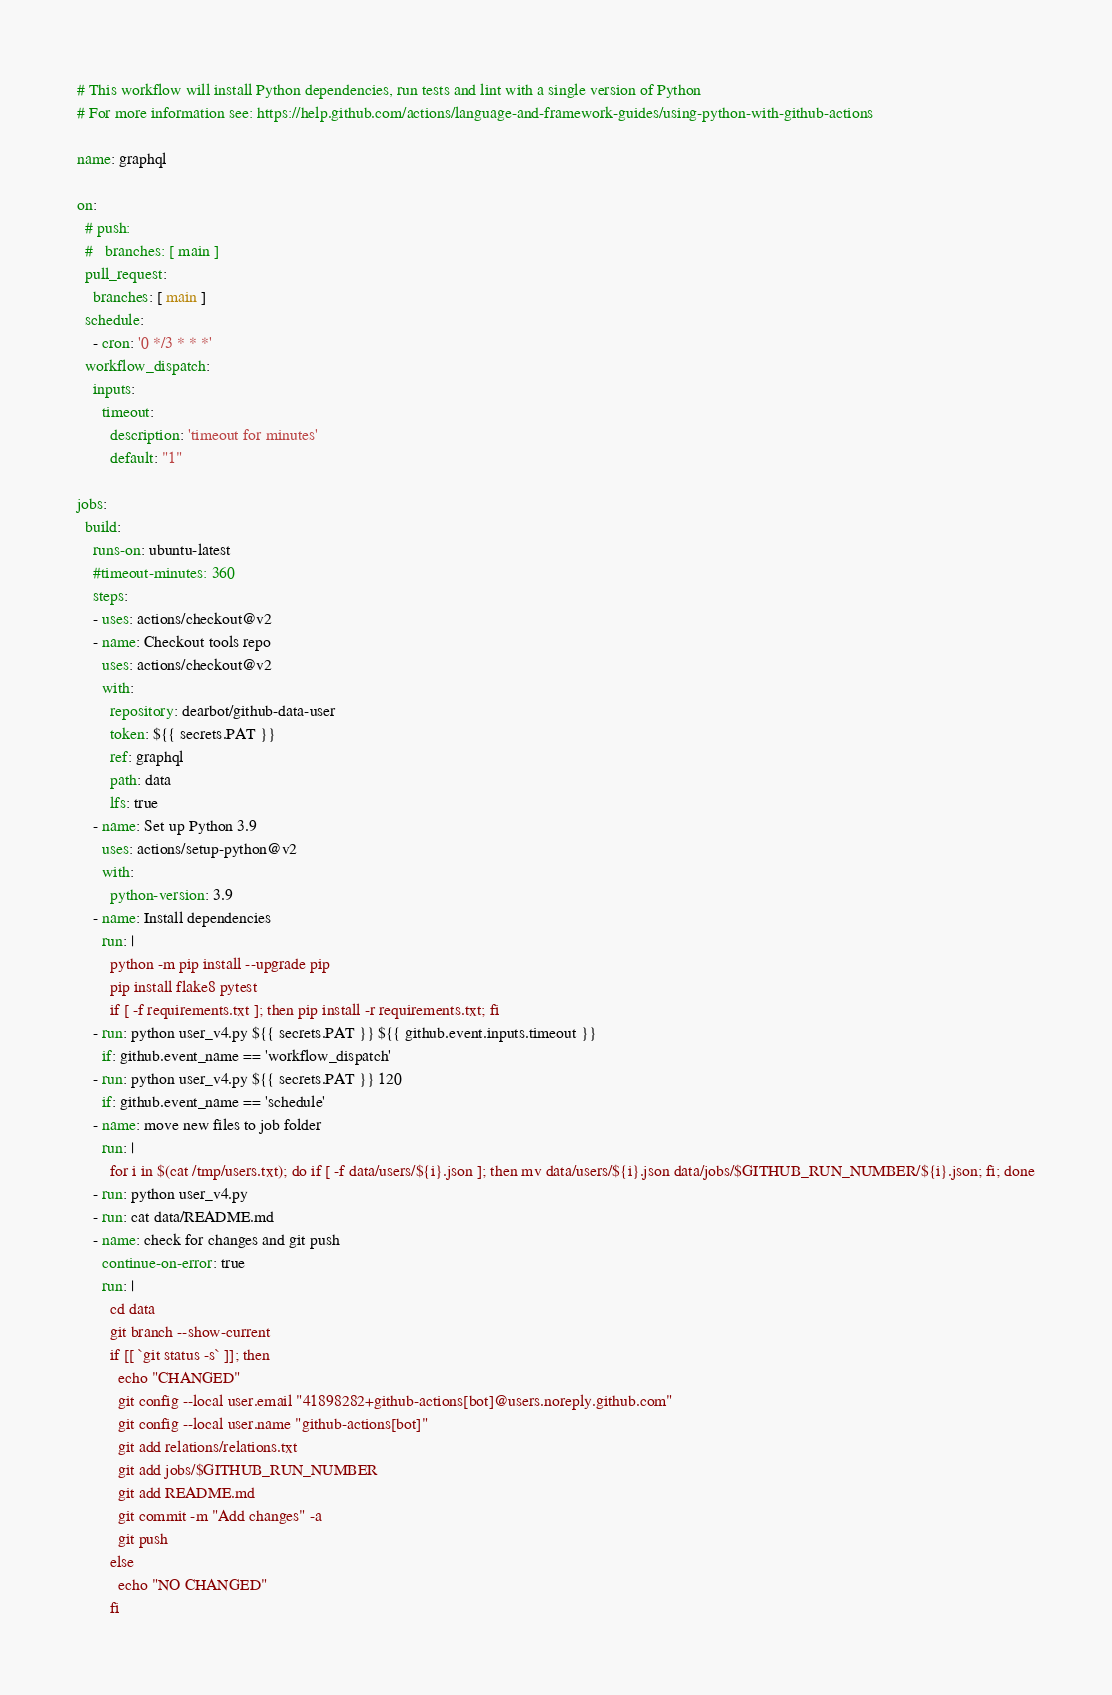<code> <loc_0><loc_0><loc_500><loc_500><_YAML_># This workflow will install Python dependencies, run tests and lint with a single version of Python
# For more information see: https://help.github.com/actions/language-and-framework-guides/using-python-with-github-actions

name: graphql

on:
  # push:
  #   branches: [ main ]
  pull_request:
    branches: [ main ]
  schedule:
    - cron: '0 */3 * * *'
  workflow_dispatch:
    inputs:
      timeout:
        description: 'timeout for minutes'     
        default: "1"
        
jobs:
  build:
    runs-on: ubuntu-latest
    #timeout-minutes: 360
    steps:
    - uses: actions/checkout@v2
    - name: Checkout tools repo
      uses: actions/checkout@v2
      with:
        repository: dearbot/github-data-user
        token: ${{ secrets.PAT }}
        ref: graphql
        path: data
        lfs: true
    - name: Set up Python 3.9
      uses: actions/setup-python@v2
      with:
        python-version: 3.9
    - name: Install dependencies
      run: |
        python -m pip install --upgrade pip
        pip install flake8 pytest
        if [ -f requirements.txt ]; then pip install -r requirements.txt; fi
    - run: python user_v4.py ${{ secrets.PAT }} ${{ github.event.inputs.timeout }}
      if: github.event_name == 'workflow_dispatch'
    - run: python user_v4.py ${{ secrets.PAT }} 120
      if: github.event_name == 'schedule'
    - name: move new files to job folder
      run: |
        for i in $(cat /tmp/users.txt); do if [ -f data/users/${i}.json ]; then mv data/users/${i}.json data/jobs/$GITHUB_RUN_NUMBER/${i}.json; fi; done
    - run: python user_v4.py
    - run: cat data/README.md
    - name: check for changes and git push
      continue-on-error: true
      run: |
        cd data
        git branch --show-current
        if [[ `git status -s` ]]; then
          echo "CHANGED"
          git config --local user.email "41898282+github-actions[bot]@users.noreply.github.com"
          git config --local user.name "github-actions[bot]"
          git add relations/relations.txt
          git add jobs/$GITHUB_RUN_NUMBER
          git add README.md
          git commit -m "Add changes" -a
          git push
        else
          echo "NO CHANGED"
        fi</code> 